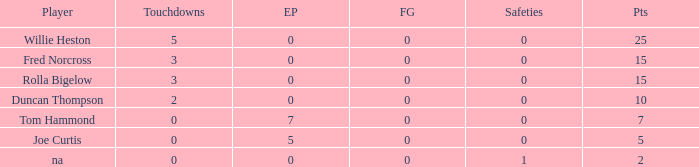Which Points is the lowest one that has Touchdowns smaller than 2, and an Extra points of 7, and a Field goals smaller than 0? None. 